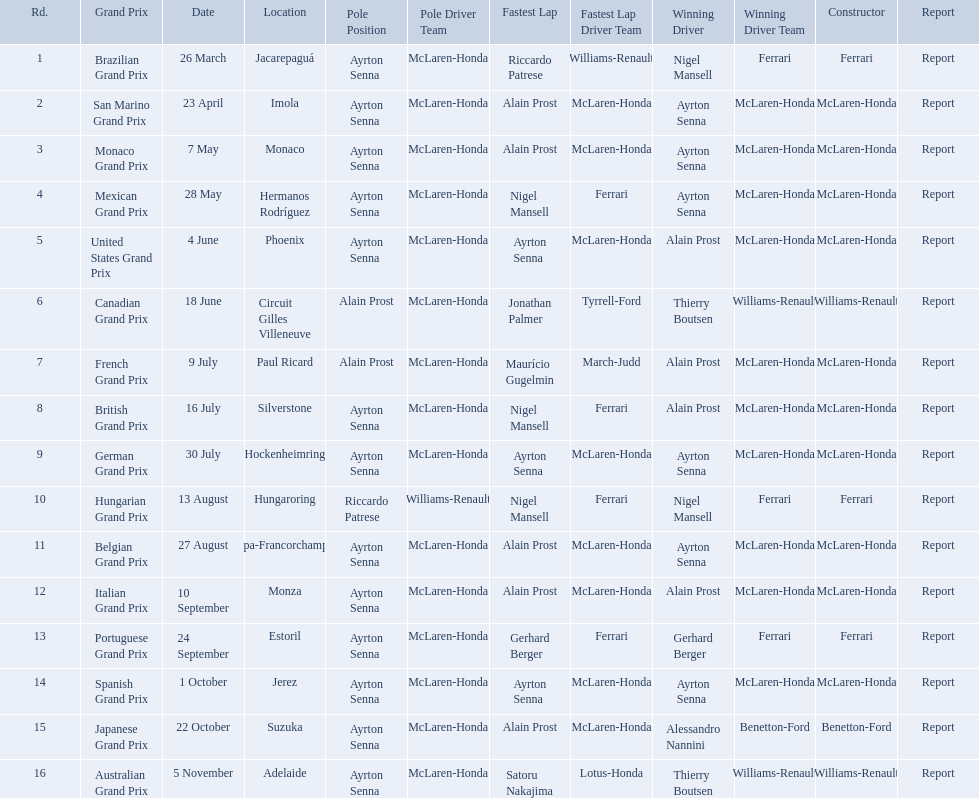Who are the constructors in the 1989 formula one season? Ferrari, McLaren-Honda, McLaren-Honda, McLaren-Honda, McLaren-Honda, Williams-Renault, McLaren-Honda, McLaren-Honda, McLaren-Honda, Ferrari, McLaren-Honda, McLaren-Honda, Ferrari, McLaren-Honda, Benetton-Ford, Williams-Renault. On what date was bennington ford the constructor? 22 October. What was the race on october 22? Japanese Grand Prix. Who won the spanish grand prix? McLaren-Honda. Who won the italian grand prix? McLaren-Honda. What grand prix did benneton-ford win? Japanese Grand Prix. 